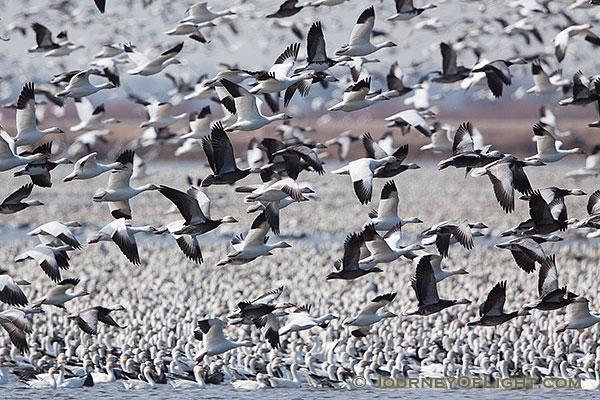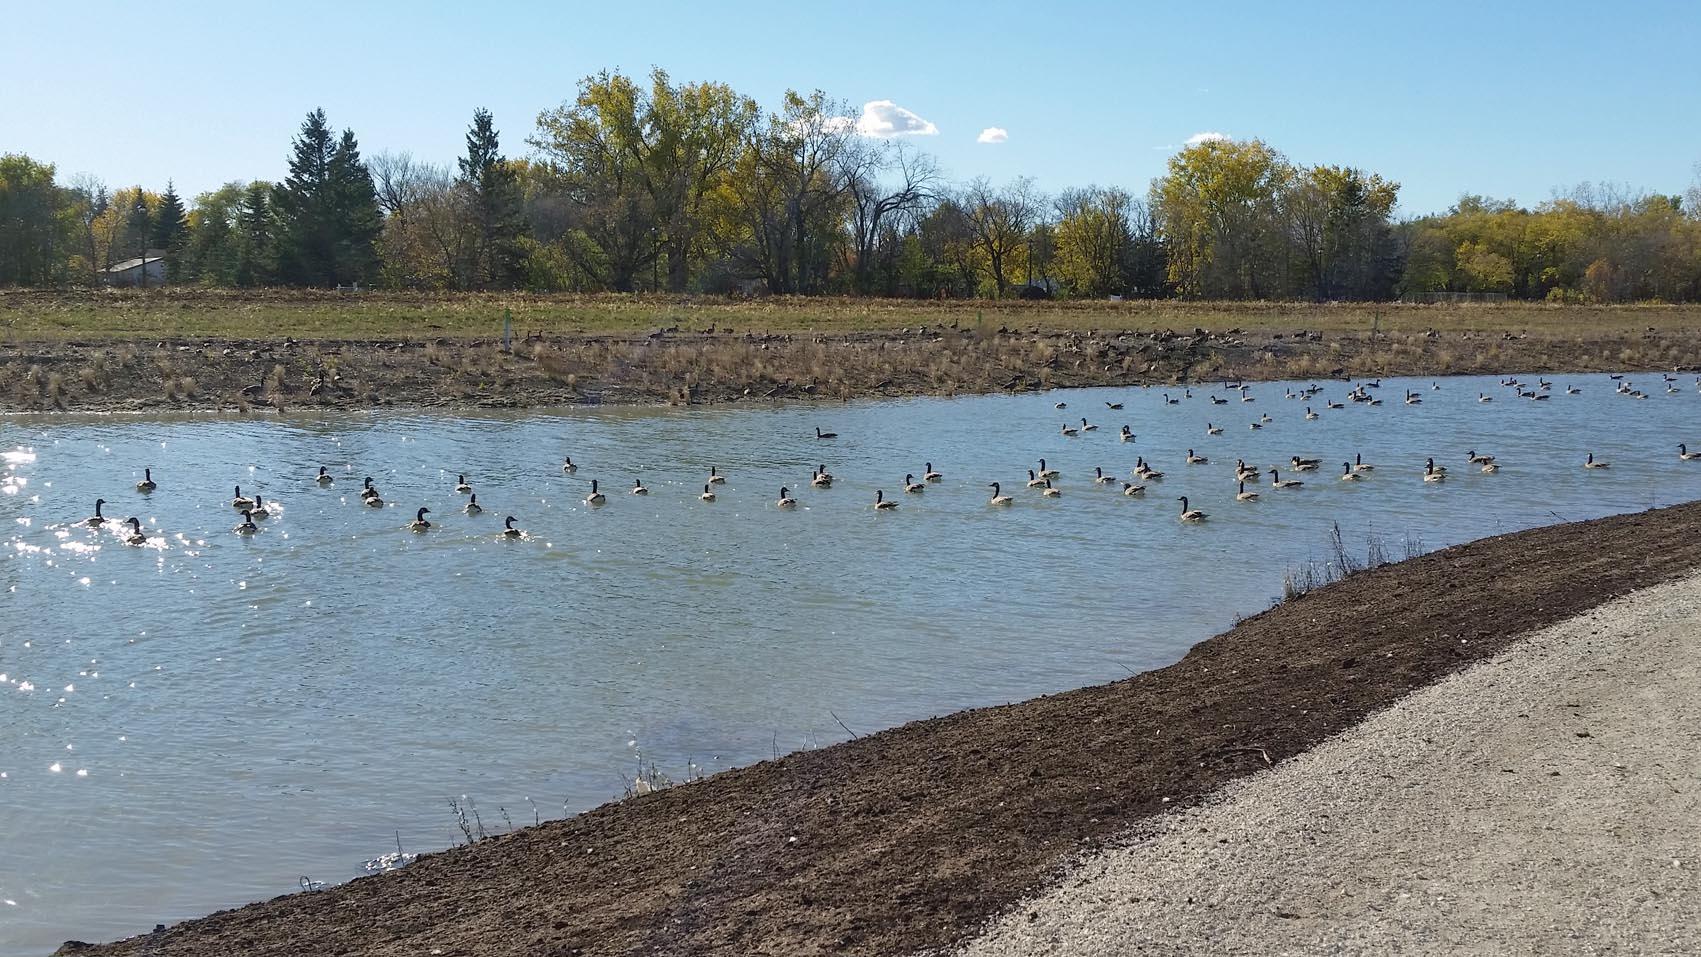The first image is the image on the left, the second image is the image on the right. For the images shown, is this caption "There are more birds in the right image than in the left." true? Answer yes or no. No. 